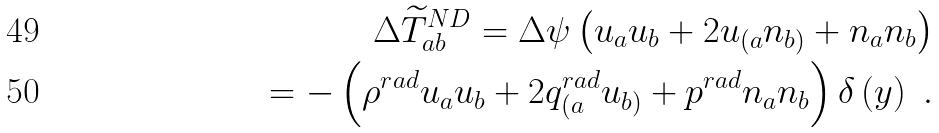Convert formula to latex. <formula><loc_0><loc_0><loc_500><loc_500>\Delta \widetilde { T } _ { a b } ^ { N D } = \Delta \psi \left ( u _ { a } u _ { b } + 2 u _ { ( a } n _ { b ) } + n _ { a } n _ { b } \right ) \\ = - \left ( \rho ^ { r a d } u _ { a } u _ { b } + 2 q _ { ( a } ^ { r a d } u _ { b ) } + p ^ { r a d } n _ { a } n _ { b } \right ) \delta \left ( y \right ) \ .</formula> 